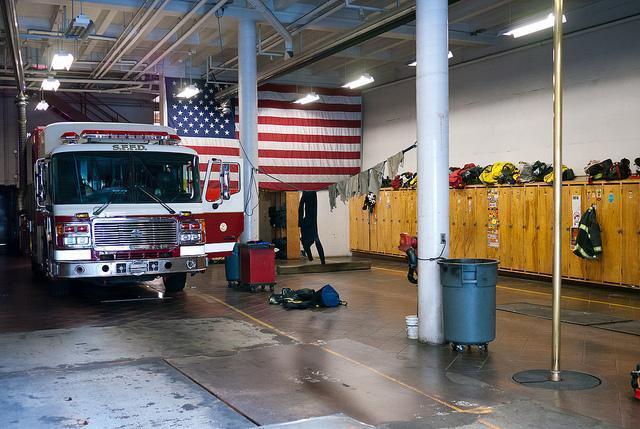How many pizzas are there?
Give a very brief answer. 0. 